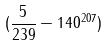<formula> <loc_0><loc_0><loc_500><loc_500>( \frac { 5 } { 2 3 9 } - 1 4 0 ^ { 2 0 7 } )</formula> 